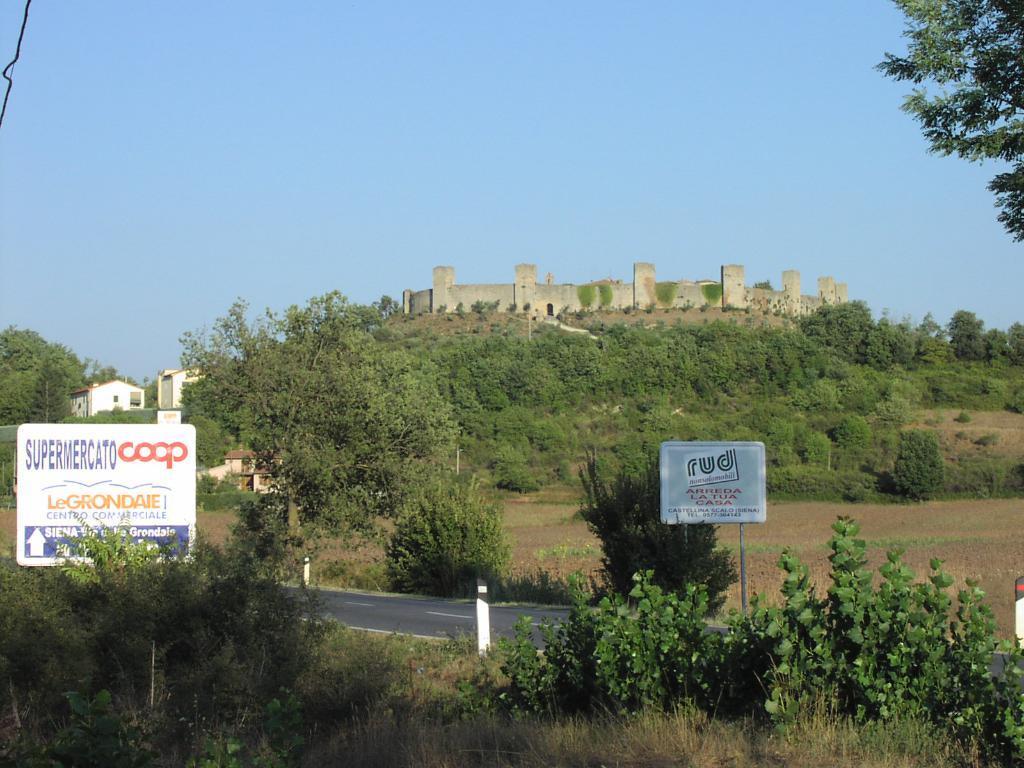Please provide a concise description of this image. In the image I can see a place where we have some trees, plants, boards and also I can see some buildings. 